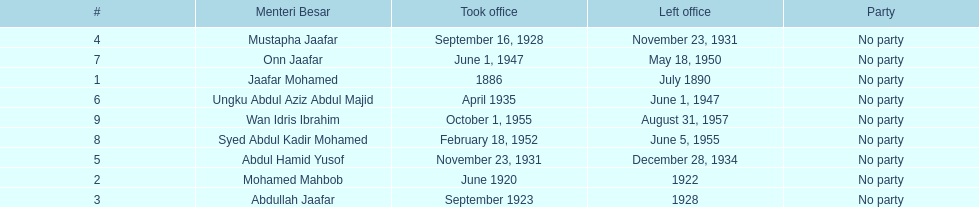Who was in office after mustapha jaafar Abdul Hamid Yusof. 